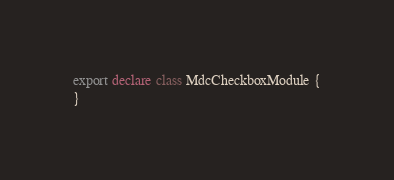<code> <loc_0><loc_0><loc_500><loc_500><_TypeScript_>export declare class MdcCheckboxModule {
}
</code> 